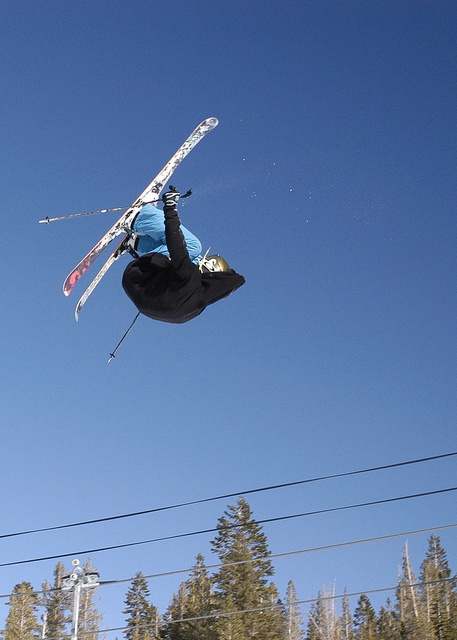Describe the objects in this image and their specific colors. I can see people in blue, black, lightblue, and navy tones and skis in blue, white, darkgray, and gray tones in this image. 